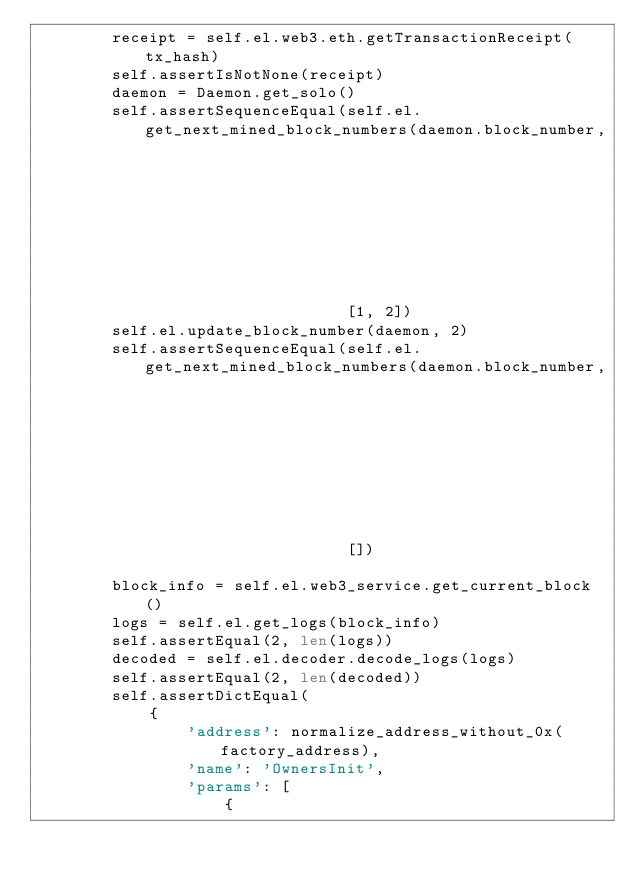<code> <loc_0><loc_0><loc_500><loc_500><_Python_>        receipt = self.el.web3.eth.getTransactionReceipt(tx_hash)
        self.assertIsNotNone(receipt)
        daemon = Daemon.get_solo()
        self.assertSequenceEqual(self.el.get_next_mined_block_numbers(daemon.block_number,
                                                                      self.el.get_current_block_number()),
                                 [1, 2])
        self.el.update_block_number(daemon, 2)
        self.assertSequenceEqual(self.el.get_next_mined_block_numbers(daemon.block_number,
                                                                      self.el.get_current_block_number()),
                                 [])

        block_info = self.el.web3_service.get_current_block()
        logs = self.el.get_logs(block_info)
        self.assertEqual(2, len(logs))
        decoded = self.el.decoder.decode_logs(logs)
        self.assertEqual(2, len(decoded))
        self.assertDictEqual(
            {
                'address': normalize_address_without_0x(factory_address),
                'name': 'OwnersInit',
                'params': [
                    {</code> 